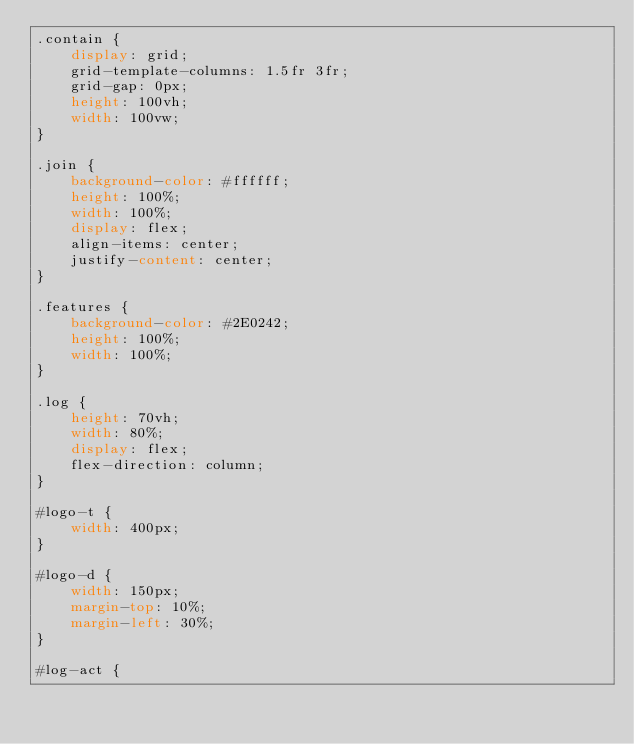<code> <loc_0><loc_0><loc_500><loc_500><_CSS_>.contain {
    display: grid;
    grid-template-columns: 1.5fr 3fr;
    grid-gap: 0px;
    height: 100vh;
    width: 100vw;
}

.join {
    background-color: #ffffff;
    height: 100%;
    width: 100%;
    display: flex;
    align-items: center;
    justify-content: center;
}

.features {
    background-color: #2E0242;
    height: 100%;
    width: 100%;
}

.log {
    height: 70vh;
    width: 80%;
    display: flex;
    flex-direction: column;
}

#logo-t {
    width: 400px;
}

#logo-d {
    width: 150px;
    margin-top: 10%;
    margin-left: 30%;
}

#log-act {</code> 